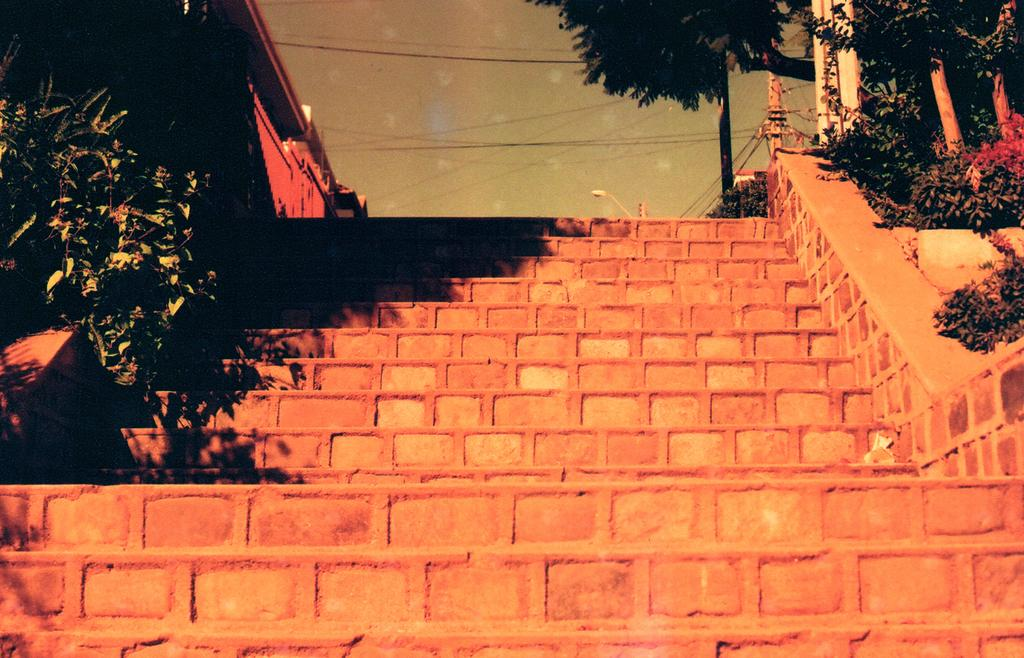What type of living organisms can be seen in the image? Plants can be seen in the image. What is visible in the background of the image? There is a building, poles, street lights, electric wires, trees, and the sky visible in the background of the image. What is the daughter doing in the image? There is no daughter present in the image. How quiet is the environment in the image? The provided facts do not mention any information about the noise level or quietness of the environment in the image. 